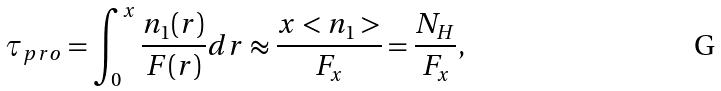<formula> <loc_0><loc_0><loc_500><loc_500>\tau _ { p r o } = \int _ { 0 } ^ { x } \frac { n _ { 1 } ( r ) } { F ( r ) } d r \approx \frac { x < n _ { 1 } > } { F _ { x } } = \frac { N _ { H } } { F _ { x } } ,</formula> 